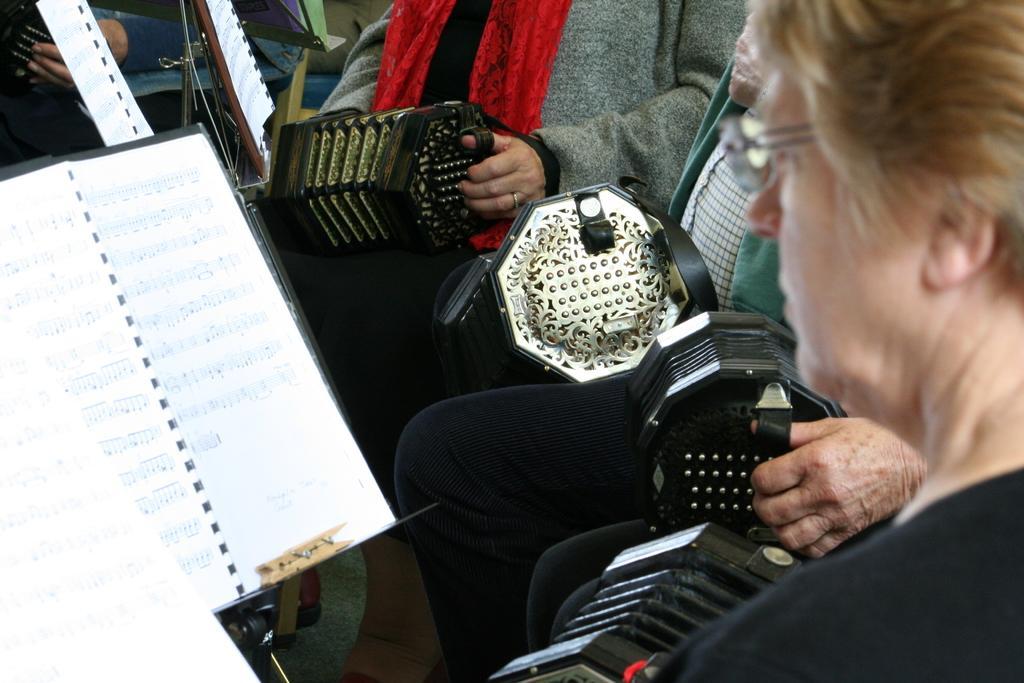Can you describe this image briefly? In this image we can see there are persons sitting on the chair and holding a musical instrument. And at the front there is a stand and a paper attached to it. 